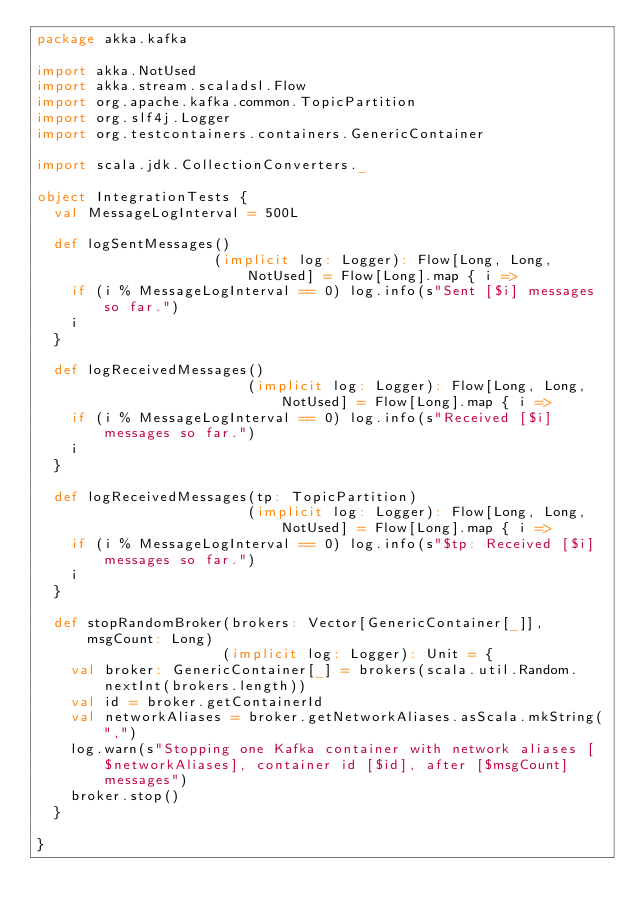<code> <loc_0><loc_0><loc_500><loc_500><_Scala_>package akka.kafka

import akka.NotUsed
import akka.stream.scaladsl.Flow
import org.apache.kafka.common.TopicPartition
import org.slf4j.Logger
import org.testcontainers.containers.GenericContainer

import scala.jdk.CollectionConverters._

object IntegrationTests {
  val MessageLogInterval = 500L

  def logSentMessages()
                     (implicit log: Logger): Flow[Long, Long, NotUsed] = Flow[Long].map { i =>
    if (i % MessageLogInterval == 0) log.info(s"Sent [$i] messages so far.")
    i
  }

  def logReceivedMessages()
                         (implicit log: Logger): Flow[Long, Long, NotUsed] = Flow[Long].map { i =>
    if (i % MessageLogInterval == 0) log.info(s"Received [$i] messages so far.")
    i
  }

  def logReceivedMessages(tp: TopicPartition)
                         (implicit log: Logger): Flow[Long, Long, NotUsed] = Flow[Long].map { i =>
    if (i % MessageLogInterval == 0) log.info(s"$tp: Received [$i] messages so far.")
    i
  }

  def stopRandomBroker(brokers: Vector[GenericContainer[_]], msgCount: Long)
                      (implicit log: Logger): Unit = {
    val broker: GenericContainer[_] = brokers(scala.util.Random.nextInt(brokers.length))
    val id = broker.getContainerId
    val networkAliases = broker.getNetworkAliases.asScala.mkString(",")
    log.warn(s"Stopping one Kafka container with network aliases [$networkAliases], container id [$id], after [$msgCount] messages")
    broker.stop()
  }

}
</code> 